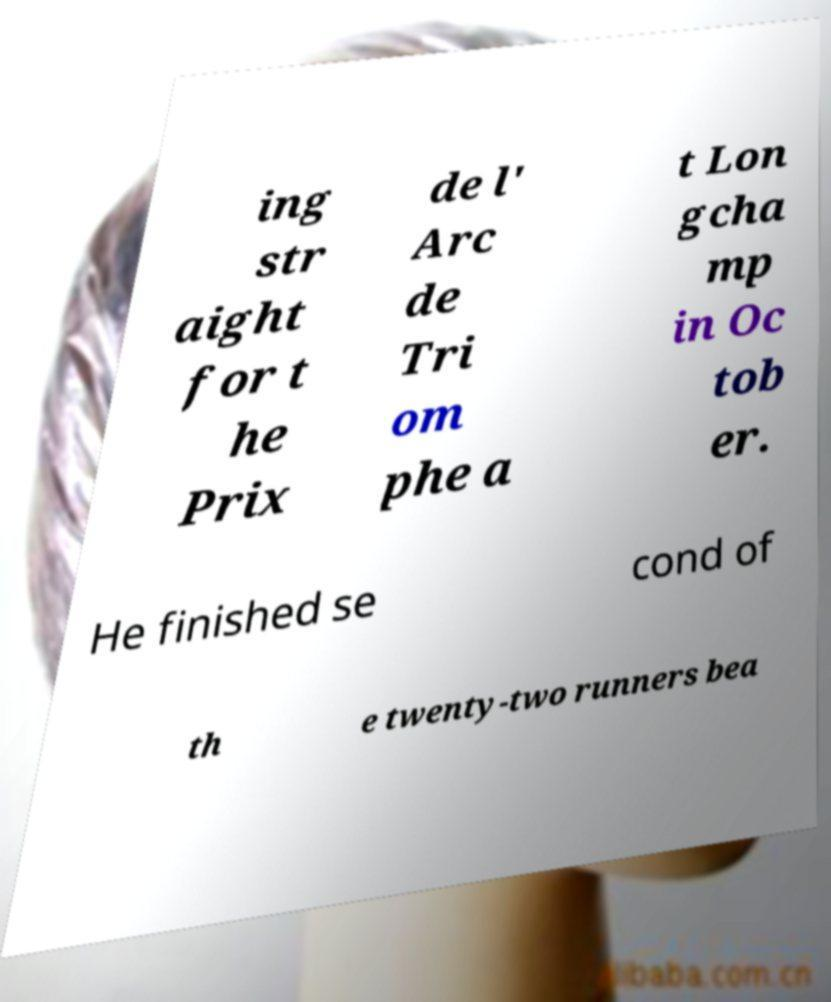Can you read and provide the text displayed in the image?This photo seems to have some interesting text. Can you extract and type it out for me? ing str aight for t he Prix de l' Arc de Tri om phe a t Lon gcha mp in Oc tob er. He finished se cond of th e twenty-two runners bea 